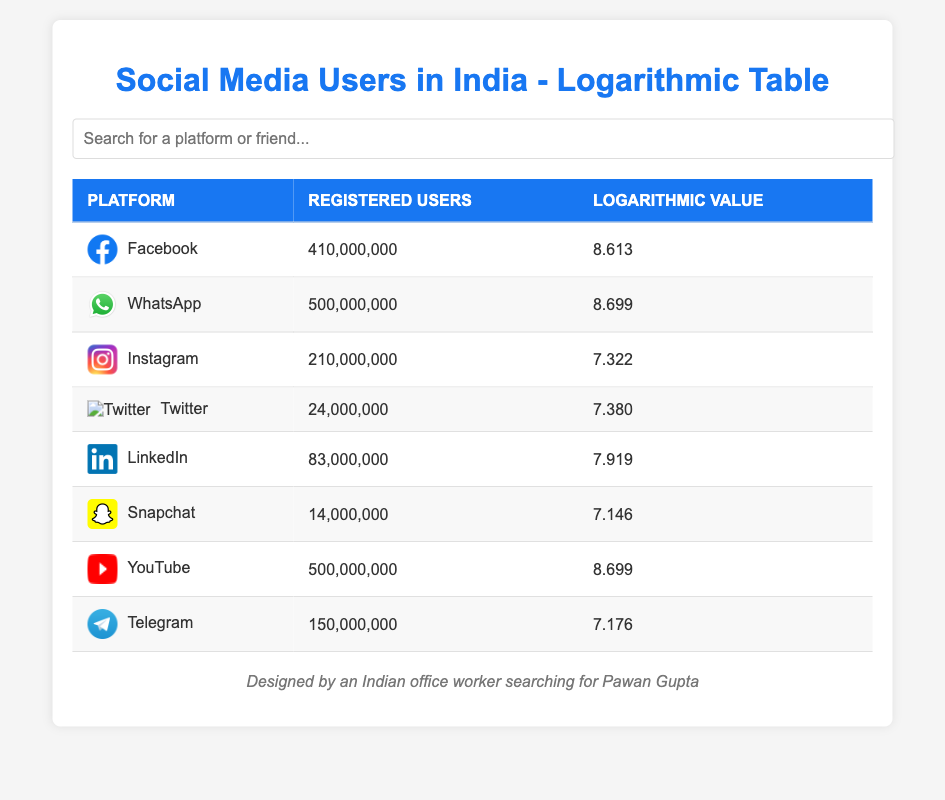What is the total number of registered users on YouTube and WhatsApp? To find the total, we need to look at the "Registered Users" column for both YouTube (500,000,000) and WhatsApp (500,000,000). Adding these together gives us 500,000,000 + 500,000,000 = 1,000,000,000.
Answer: 1,000,000,000 Which social media platform has the highest logarithmic value? In the "Logarithmic Value" column, we see that WhatsApp and YouTube both have a logarithmic value of 8.699, which is the highest among all listed platforms.
Answer: WhatsApp and YouTube Is the number of registered users on Snapchat greater than that on Instagram? The "Registered Users" for Snapchat is 14,000,000, while for Instagram it is 210,000,000. Since 14,000,000 is less than 210,000,000, the statement is false.
Answer: No What is the average number of registered users for all platforms listed? To calculate the average, we first need to sum the registered users from each platform: 410,000,000 + 500,000,000 + 210,000,000 + 24,000,000 + 83,000,000 + 14,000,000 + 500,000,000 + 150,000,000 = 1,891,000,000. There are 8 platforms, so we divide the sum by 8: 1,891,000,000 / 8 = 236,375,000.
Answer: 236,375,000 Does LinkedIn have a lower registered user count than Twitter? LinkedIn has 83,000,000 registered users, while Twitter has 24,000,000. Since 83,000,000 is greater than 24,000,000, the statement is false.
Answer: No 